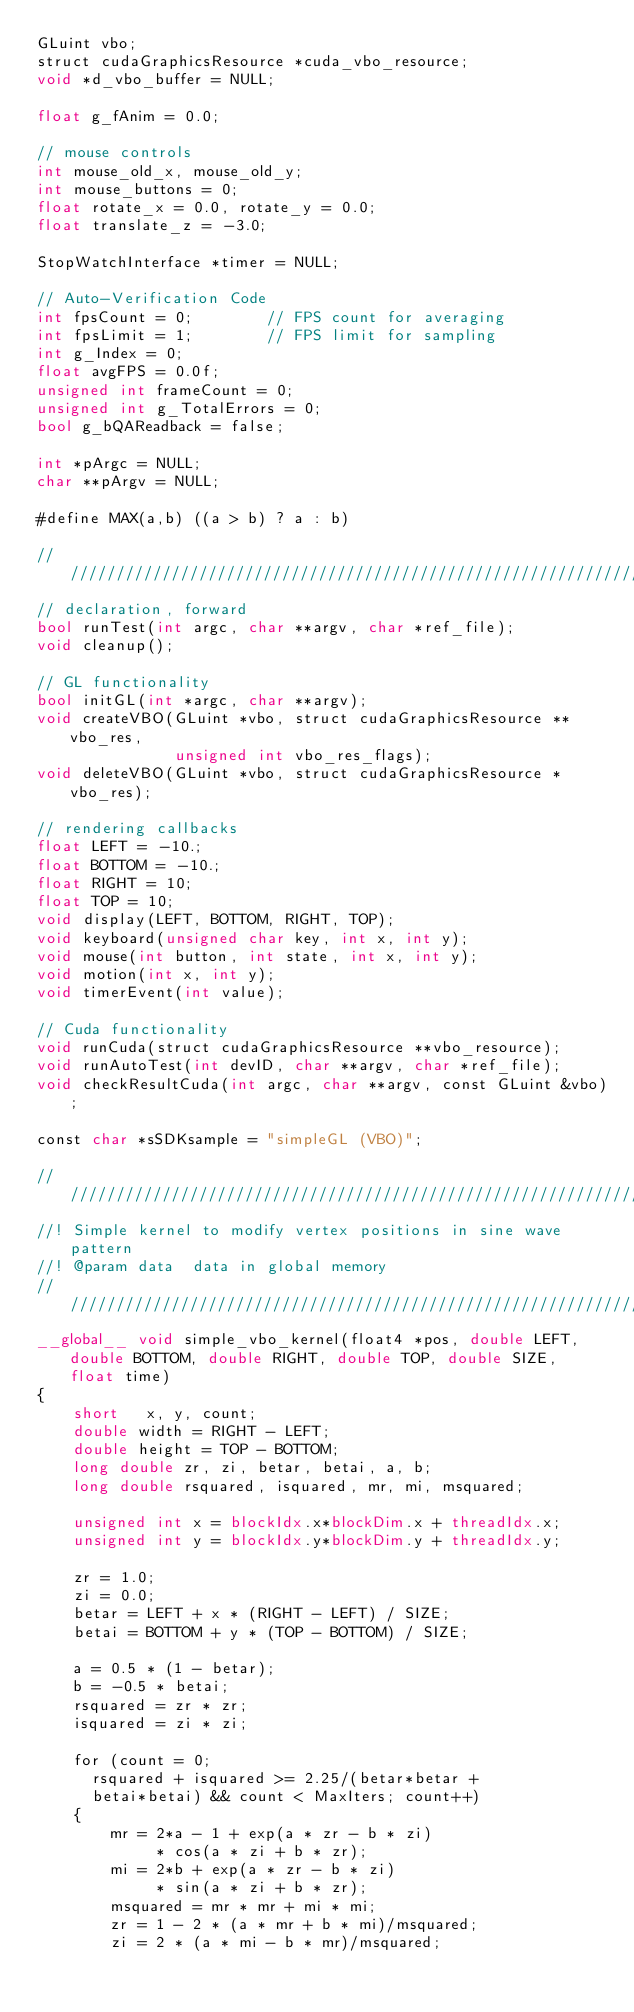<code> <loc_0><loc_0><loc_500><loc_500><_Cuda_>GLuint vbo;
struct cudaGraphicsResource *cuda_vbo_resource;
void *d_vbo_buffer = NULL;

float g_fAnim = 0.0;

// mouse controls
int mouse_old_x, mouse_old_y;
int mouse_buttons = 0;
float rotate_x = 0.0, rotate_y = 0.0;
float translate_z = -3.0;

StopWatchInterface *timer = NULL;

// Auto-Verification Code
int fpsCount = 0;        // FPS count for averaging
int fpsLimit = 1;        // FPS limit for sampling
int g_Index = 0;
float avgFPS = 0.0f;
unsigned int frameCount = 0;
unsigned int g_TotalErrors = 0;
bool g_bQAReadback = false;

int *pArgc = NULL;
char **pArgv = NULL;

#define MAX(a,b) ((a > b) ? a : b)

////////////////////////////////////////////////////////////////////////////////
// declaration, forward
bool runTest(int argc, char **argv, char *ref_file);
void cleanup();

// GL functionality
bool initGL(int *argc, char **argv);
void createVBO(GLuint *vbo, struct cudaGraphicsResource **vbo_res,
               unsigned int vbo_res_flags);
void deleteVBO(GLuint *vbo, struct cudaGraphicsResource *vbo_res);

// rendering callbacks
float LEFT = -10.;
float BOTTOM = -10.;
float RIGHT = 10;
float TOP = 10;
void display(LEFT, BOTTOM, RIGHT, TOP);
void keyboard(unsigned char key, int x, int y);
void mouse(int button, int state, int x, int y);
void motion(int x, int y);
void timerEvent(int value);

// Cuda functionality
void runCuda(struct cudaGraphicsResource **vbo_resource);
void runAutoTest(int devID, char **argv, char *ref_file);
void checkResultCuda(int argc, char **argv, const GLuint &vbo);

const char *sSDKsample = "simpleGL (VBO)";

///////////////////////////////////////////////////////////////////////////////
//! Simple kernel to modify vertex positions in sine wave pattern
//! @param data  data in global memory
///////////////////////////////////////////////////////////////////////////////
__global__ void simple_vbo_kernel(float4 *pos, double LEFT, double BOTTOM, double RIGHT, double TOP, double SIZE, float time)
{
    short   x, y, count; 
    double width = RIGHT - LEFT;
    double height = TOP - BOTTOM;
    long double zr, zi, betar, betai, a, b; 
    long double rsquared, isquared, mr, mi, msquared; 

    unsigned int x = blockIdx.x*blockDim.x + threadIdx.x;
    unsigned int y = blockIdx.y*blockDim.y + threadIdx.y;

    zr = 1.0;
    zi = 0.0;
    betar = LEFT + x * (RIGHT - LEFT) / SIZE; 
    betai = BOTTOM + y * (TOP - BOTTOM) / SIZE;  

    a = 0.5 * (1 - betar);    
    b = -0.5 * betai;       
    rsquared = zr * zr; 
    isquared = zi * zi; 

    for (count = 0; 
      rsquared + isquared >= 2.25/(betar*betar + 
      betai*betai) && count < MaxIters; count++)    
    { 
        mr = 2*a - 1 + exp(a * zr - b * zi) 
             * cos(a * zi + b * zr); 
        mi = 2*b + exp(a * zr - b * zi) 
             * sin(a * zi + b * zr); 
        msquared = mr * mr + mi * mi; 
        zr = 1 - 2 * (a * mr + b * mi)/msquared;   
        zi = 2 * (a * mi - b * mr)/msquared;       </code> 